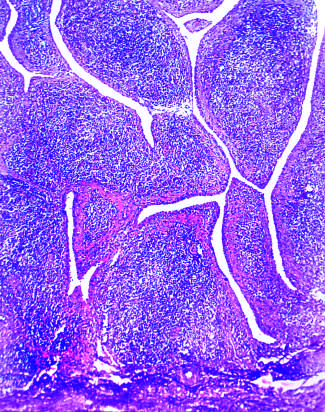what shows marked synovial hypertrophy with formation of villi?
Answer the question using a single word or phrase. Low magnification 